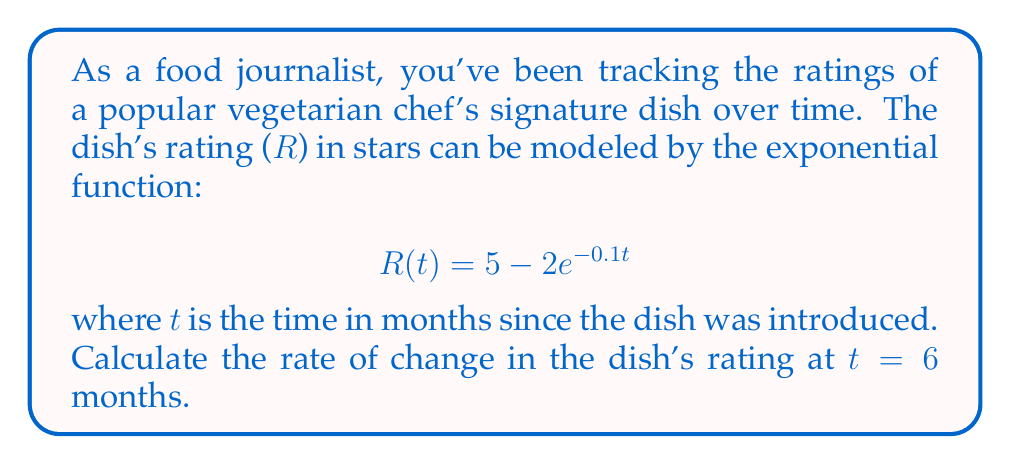What is the answer to this math problem? To find the rate of change in the dish's rating at t = 6 months, we need to calculate the derivative of the given function and evaluate it at t = 6.

Step 1: Calculate the derivative of R(t)
The derivative of $R(t) = 5 - 2e^{-0.1t}$ is:
$$R'(t) = -2 \cdot (-0.1) \cdot e^{-0.1t} = 0.2e^{-0.1t}$$

Step 2: Evaluate R'(t) at t = 6
$$R'(6) = 0.2e^{-0.1(6)} = 0.2e^{-0.6}$$

Step 3: Calculate the final value
$$R'(6) = 0.2 \cdot e^{-0.6} \approx 0.1097$$

The rate of change at t = 6 months is approximately 0.1097 stars per month.
Answer: 0.1097 stars/month 